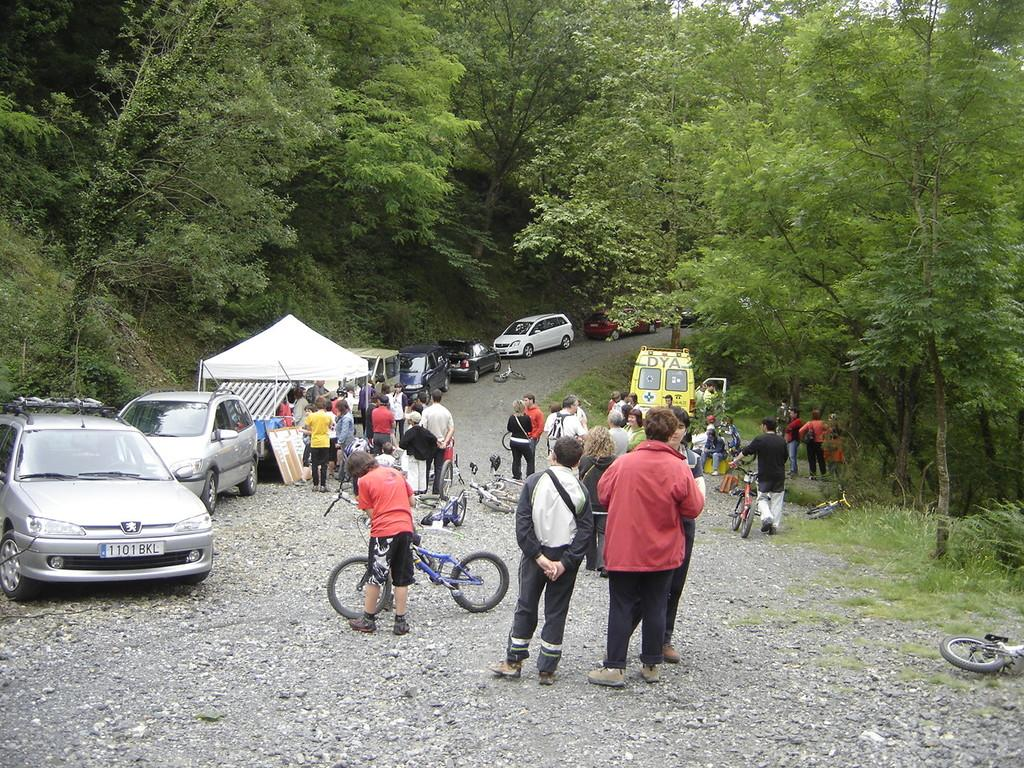What is the main feature of the image? There is a road in the image. What is happening on the road? People, bicycles, cars, and a van are visible on the road. Are there any other structures or objects on the road? Yes, there is a stall on the road. What can be seen in the background of the image? Trees are visible at the top of the image. How many dogs are present at the good-bye party in the image? There are no dogs or good-bye parties present in the image; it features a road with various vehicles and people. 